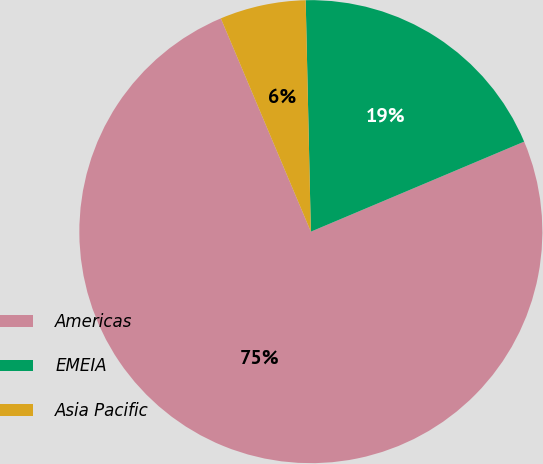Convert chart to OTSL. <chart><loc_0><loc_0><loc_500><loc_500><pie_chart><fcel>Americas<fcel>EMEIA<fcel>Asia Pacific<nl><fcel>75.0%<fcel>19.0%<fcel>6.0%<nl></chart> 